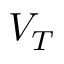<formula> <loc_0><loc_0><loc_500><loc_500>V _ { T }</formula> 